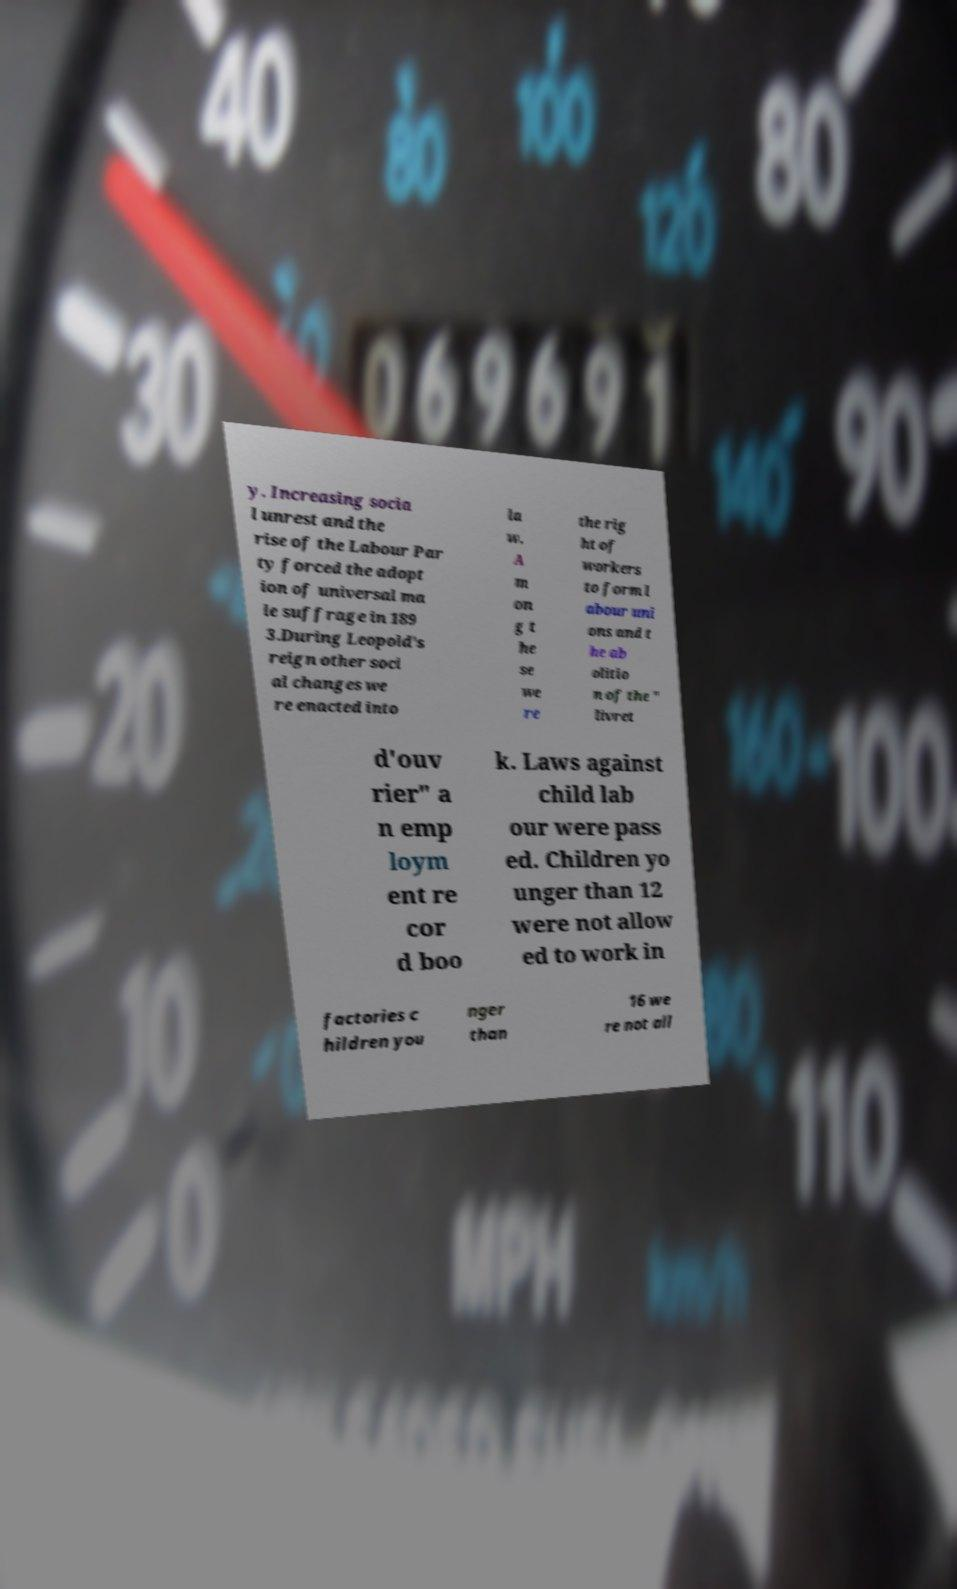For documentation purposes, I need the text within this image transcribed. Could you provide that? y. Increasing socia l unrest and the rise of the Labour Par ty forced the adopt ion of universal ma le suffrage in 189 3.During Leopold's reign other soci al changes we re enacted into la w. A m on g t he se we re the rig ht of workers to form l abour uni ons and t he ab olitio n of the " livret d'ouv rier" a n emp loym ent re cor d boo k. Laws against child lab our were pass ed. Children yo unger than 12 were not allow ed to work in factories c hildren you nger than 16 we re not all 